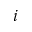Convert formula to latex. <formula><loc_0><loc_0><loc_500><loc_500>i</formula> 